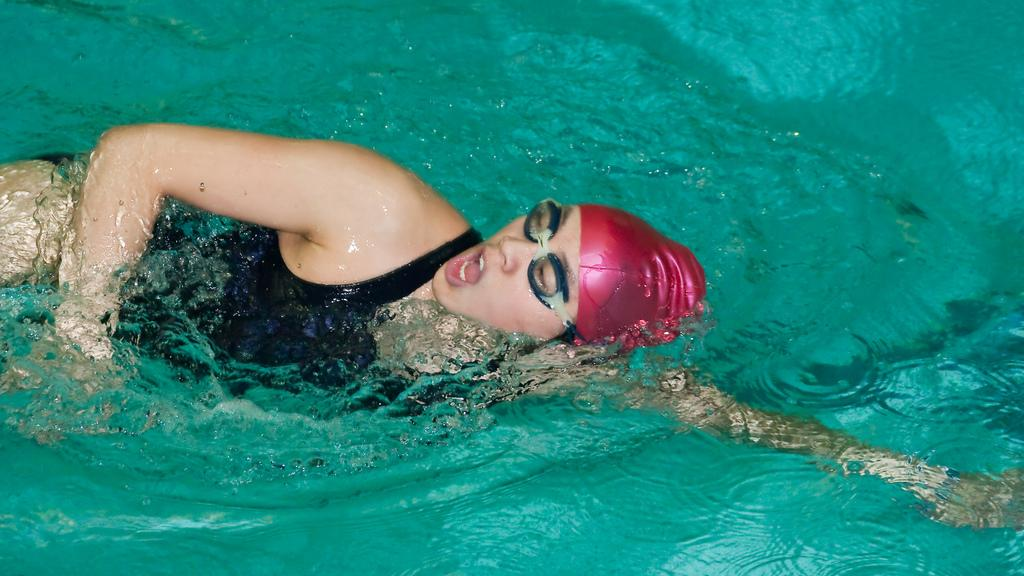Who is the main subject in the image? There is a woman in the image. What is the woman doing in the image? The woman is swimming in the water. Are there any accessories or clothing items visible on the woman? Yes, the woman is wearing spectacles and has a cap on her head. What can be seen in the background of the image? The background of the image includes water. What type of flowers can be seen growing near the tramp in the image? There is no tramp or flowers present in the image; it features a woman swimming in the water. 